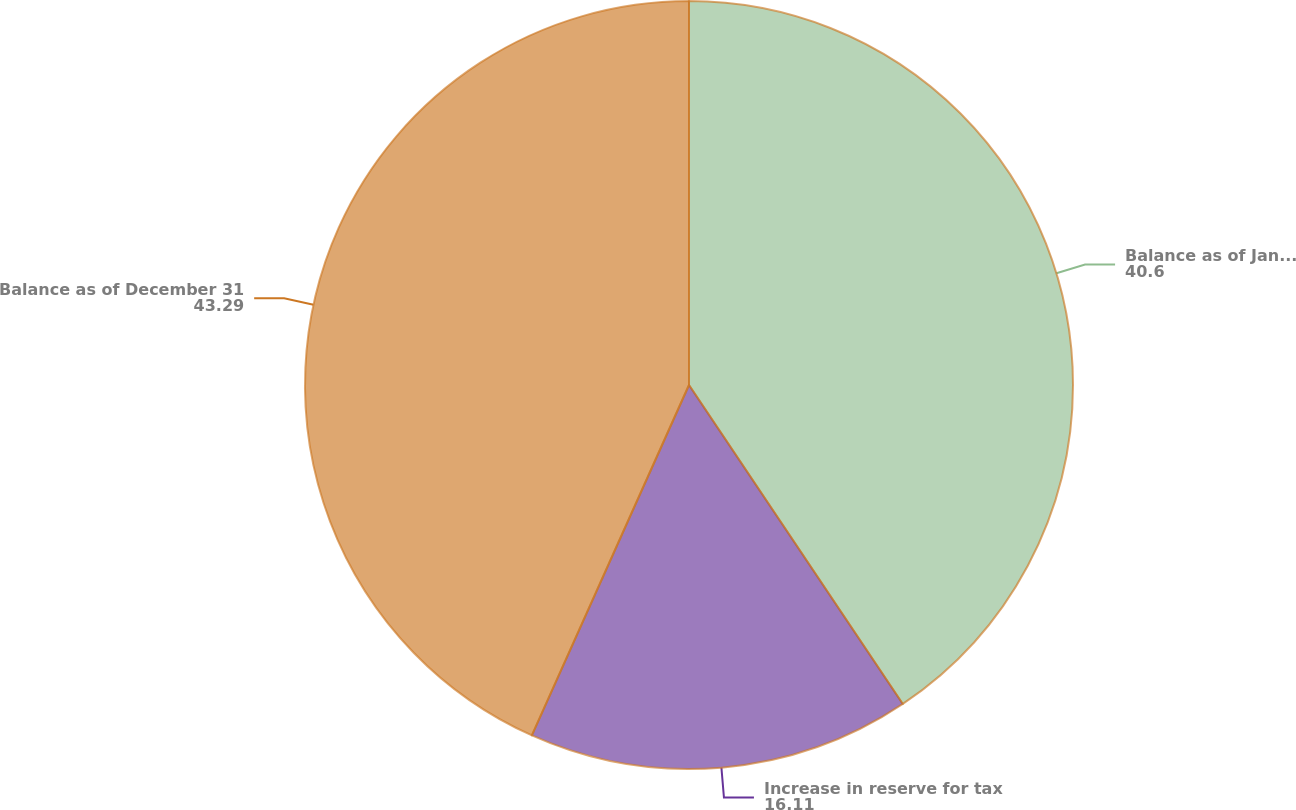<chart> <loc_0><loc_0><loc_500><loc_500><pie_chart><fcel>Balance as of January 1<fcel>Increase in reserve for tax<fcel>Balance as of December 31<nl><fcel>40.6%<fcel>16.11%<fcel>43.29%<nl></chart> 